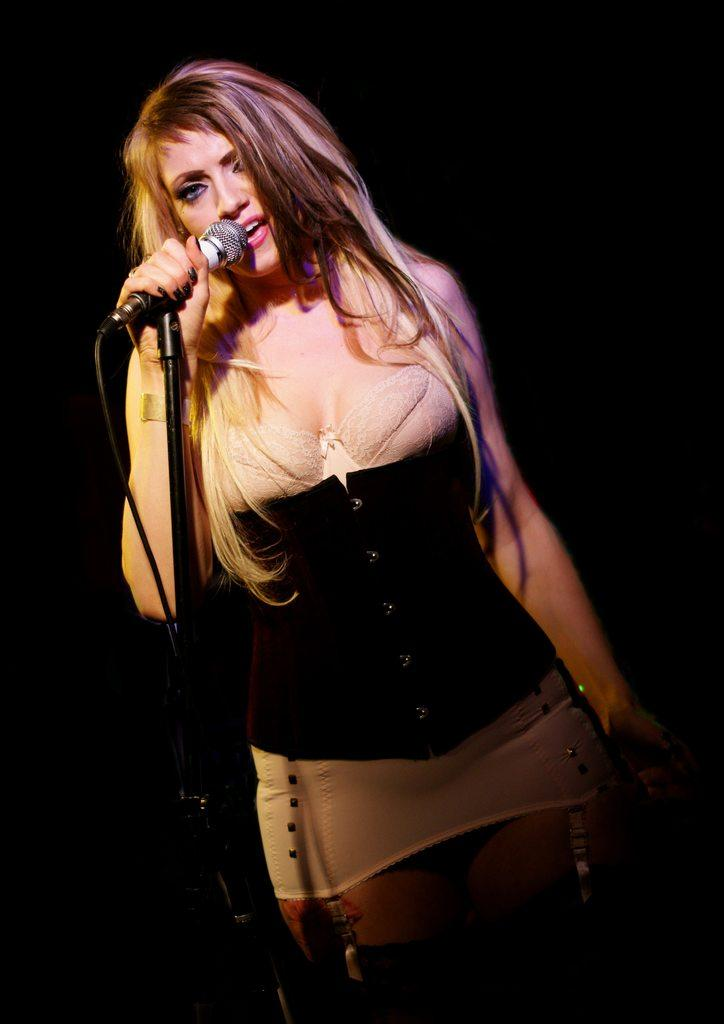Who is the main subject in the image? There is a woman in the image. What is the woman doing in the image? The woman is standing and holding a mic in her hand. What is the title of the song the woman is singing in the image? There is no indication in the image that the woman is singing a song, so it cannot be determined from the picture. 